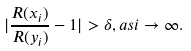<formula> <loc_0><loc_0><loc_500><loc_500>| \frac { R ( x _ { i } ) } { R ( y _ { i } ) } - 1 | > \delta , a s i \rightarrow \infty .</formula> 